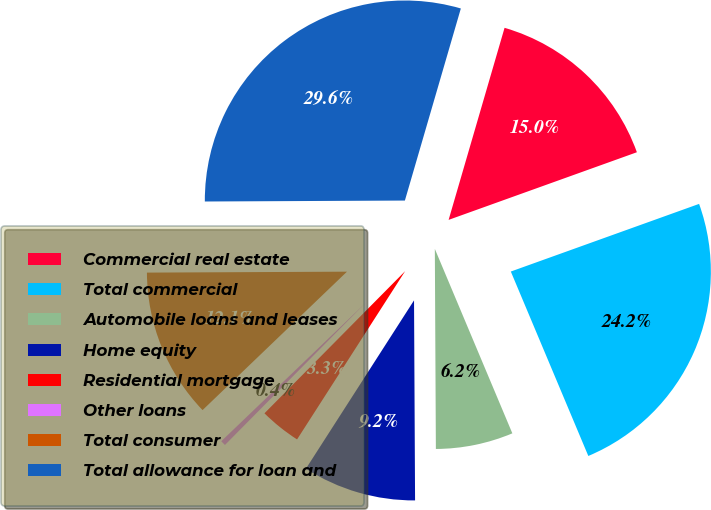Convert chart to OTSL. <chart><loc_0><loc_0><loc_500><loc_500><pie_chart><fcel>Commercial real estate<fcel>Total commercial<fcel>Automobile loans and leases<fcel>Home equity<fcel>Residential mortgage<fcel>Other loans<fcel>Total consumer<fcel>Total allowance for loan and<nl><fcel>15.0%<fcel>24.16%<fcel>6.25%<fcel>9.17%<fcel>3.33%<fcel>0.42%<fcel>12.09%<fcel>29.59%<nl></chart> 